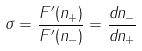<formula> <loc_0><loc_0><loc_500><loc_500>\sigma = \frac { F ^ { \prime } ( n _ { + } ) } { F ^ { \prime } ( n _ { - } ) } = \frac { d n _ { - } } { d n _ { + } }</formula> 